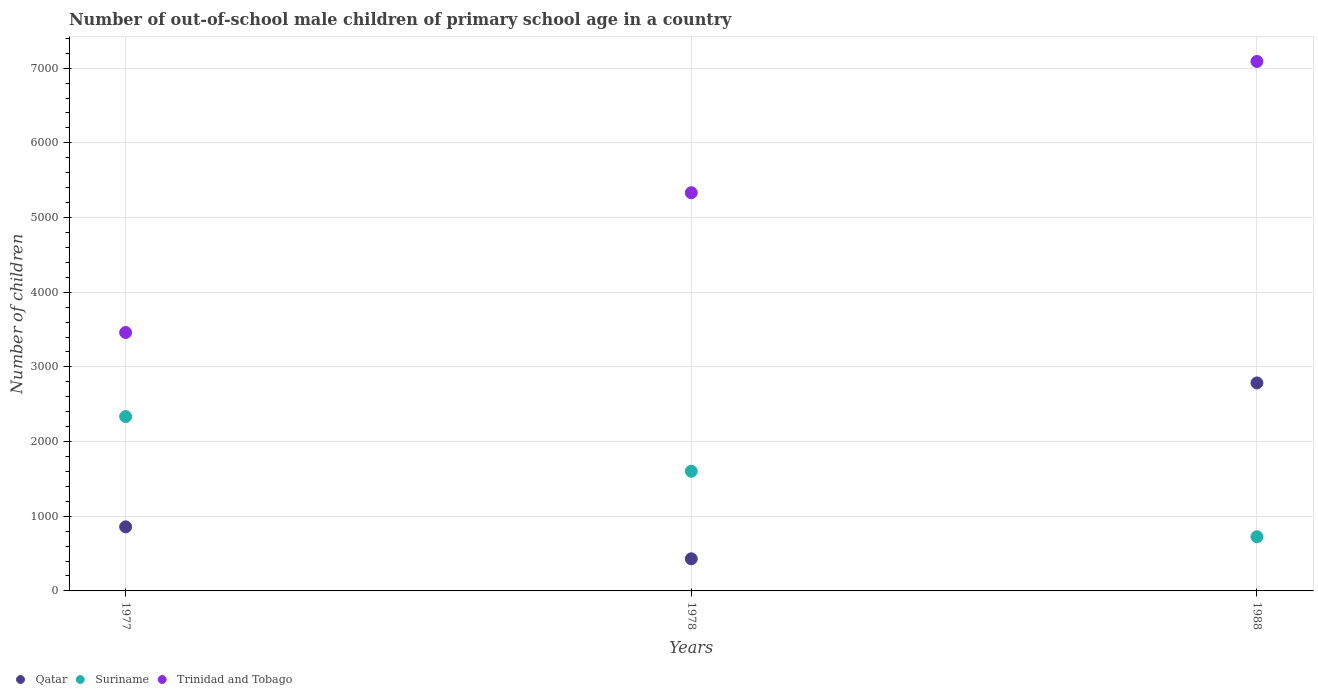How many different coloured dotlines are there?
Offer a very short reply. 3. What is the number of out-of-school male children in Suriname in 1977?
Provide a succinct answer. 2335. Across all years, what is the maximum number of out-of-school male children in Qatar?
Provide a short and direct response. 2785. Across all years, what is the minimum number of out-of-school male children in Qatar?
Ensure brevity in your answer.  430. In which year was the number of out-of-school male children in Qatar minimum?
Your answer should be very brief. 1978. What is the total number of out-of-school male children in Qatar in the graph?
Give a very brief answer. 4073. What is the difference between the number of out-of-school male children in Trinidad and Tobago in 1977 and that in 1988?
Offer a terse response. -3630. What is the difference between the number of out-of-school male children in Qatar in 1988 and the number of out-of-school male children in Trinidad and Tobago in 1978?
Ensure brevity in your answer.  -2547. What is the average number of out-of-school male children in Suriname per year?
Give a very brief answer. 1554.33. In the year 1978, what is the difference between the number of out-of-school male children in Qatar and number of out-of-school male children in Trinidad and Tobago?
Give a very brief answer. -4902. In how many years, is the number of out-of-school male children in Suriname greater than 5800?
Your response must be concise. 0. What is the ratio of the number of out-of-school male children in Suriname in 1977 to that in 1988?
Your answer should be very brief. 3.22. Is the number of out-of-school male children in Qatar in 1977 less than that in 1988?
Your response must be concise. Yes. What is the difference between the highest and the second highest number of out-of-school male children in Trinidad and Tobago?
Provide a short and direct response. 1758. What is the difference between the highest and the lowest number of out-of-school male children in Trinidad and Tobago?
Provide a short and direct response. 3630. Is it the case that in every year, the sum of the number of out-of-school male children in Trinidad and Tobago and number of out-of-school male children in Suriname  is greater than the number of out-of-school male children in Qatar?
Make the answer very short. Yes. Does the graph contain any zero values?
Your answer should be very brief. No. Does the graph contain grids?
Give a very brief answer. Yes. How many legend labels are there?
Your response must be concise. 3. What is the title of the graph?
Make the answer very short. Number of out-of-school male children of primary school age in a country. What is the label or title of the Y-axis?
Make the answer very short. Number of children. What is the Number of children in Qatar in 1977?
Your answer should be very brief. 858. What is the Number of children of Suriname in 1977?
Ensure brevity in your answer.  2335. What is the Number of children of Trinidad and Tobago in 1977?
Give a very brief answer. 3460. What is the Number of children of Qatar in 1978?
Offer a terse response. 430. What is the Number of children of Suriname in 1978?
Give a very brief answer. 1602. What is the Number of children in Trinidad and Tobago in 1978?
Offer a very short reply. 5332. What is the Number of children of Qatar in 1988?
Provide a succinct answer. 2785. What is the Number of children in Suriname in 1988?
Keep it short and to the point. 726. What is the Number of children of Trinidad and Tobago in 1988?
Your answer should be very brief. 7090. Across all years, what is the maximum Number of children of Qatar?
Provide a succinct answer. 2785. Across all years, what is the maximum Number of children in Suriname?
Ensure brevity in your answer.  2335. Across all years, what is the maximum Number of children of Trinidad and Tobago?
Provide a succinct answer. 7090. Across all years, what is the minimum Number of children in Qatar?
Make the answer very short. 430. Across all years, what is the minimum Number of children in Suriname?
Provide a succinct answer. 726. Across all years, what is the minimum Number of children in Trinidad and Tobago?
Your response must be concise. 3460. What is the total Number of children of Qatar in the graph?
Ensure brevity in your answer.  4073. What is the total Number of children of Suriname in the graph?
Give a very brief answer. 4663. What is the total Number of children of Trinidad and Tobago in the graph?
Provide a short and direct response. 1.59e+04. What is the difference between the Number of children in Qatar in 1977 and that in 1978?
Offer a very short reply. 428. What is the difference between the Number of children of Suriname in 1977 and that in 1978?
Your answer should be compact. 733. What is the difference between the Number of children of Trinidad and Tobago in 1977 and that in 1978?
Your response must be concise. -1872. What is the difference between the Number of children of Qatar in 1977 and that in 1988?
Your response must be concise. -1927. What is the difference between the Number of children in Suriname in 1977 and that in 1988?
Give a very brief answer. 1609. What is the difference between the Number of children of Trinidad and Tobago in 1977 and that in 1988?
Provide a short and direct response. -3630. What is the difference between the Number of children in Qatar in 1978 and that in 1988?
Give a very brief answer. -2355. What is the difference between the Number of children in Suriname in 1978 and that in 1988?
Make the answer very short. 876. What is the difference between the Number of children in Trinidad and Tobago in 1978 and that in 1988?
Provide a short and direct response. -1758. What is the difference between the Number of children in Qatar in 1977 and the Number of children in Suriname in 1978?
Your response must be concise. -744. What is the difference between the Number of children in Qatar in 1977 and the Number of children in Trinidad and Tobago in 1978?
Offer a terse response. -4474. What is the difference between the Number of children of Suriname in 1977 and the Number of children of Trinidad and Tobago in 1978?
Offer a very short reply. -2997. What is the difference between the Number of children in Qatar in 1977 and the Number of children in Suriname in 1988?
Provide a succinct answer. 132. What is the difference between the Number of children in Qatar in 1977 and the Number of children in Trinidad and Tobago in 1988?
Keep it short and to the point. -6232. What is the difference between the Number of children of Suriname in 1977 and the Number of children of Trinidad and Tobago in 1988?
Offer a terse response. -4755. What is the difference between the Number of children of Qatar in 1978 and the Number of children of Suriname in 1988?
Your answer should be compact. -296. What is the difference between the Number of children of Qatar in 1978 and the Number of children of Trinidad and Tobago in 1988?
Ensure brevity in your answer.  -6660. What is the difference between the Number of children in Suriname in 1978 and the Number of children in Trinidad and Tobago in 1988?
Your answer should be very brief. -5488. What is the average Number of children in Qatar per year?
Your answer should be very brief. 1357.67. What is the average Number of children of Suriname per year?
Your response must be concise. 1554.33. What is the average Number of children in Trinidad and Tobago per year?
Your answer should be very brief. 5294. In the year 1977, what is the difference between the Number of children of Qatar and Number of children of Suriname?
Provide a succinct answer. -1477. In the year 1977, what is the difference between the Number of children of Qatar and Number of children of Trinidad and Tobago?
Offer a very short reply. -2602. In the year 1977, what is the difference between the Number of children in Suriname and Number of children in Trinidad and Tobago?
Provide a succinct answer. -1125. In the year 1978, what is the difference between the Number of children in Qatar and Number of children in Suriname?
Your answer should be very brief. -1172. In the year 1978, what is the difference between the Number of children in Qatar and Number of children in Trinidad and Tobago?
Keep it short and to the point. -4902. In the year 1978, what is the difference between the Number of children in Suriname and Number of children in Trinidad and Tobago?
Provide a succinct answer. -3730. In the year 1988, what is the difference between the Number of children of Qatar and Number of children of Suriname?
Offer a terse response. 2059. In the year 1988, what is the difference between the Number of children of Qatar and Number of children of Trinidad and Tobago?
Make the answer very short. -4305. In the year 1988, what is the difference between the Number of children in Suriname and Number of children in Trinidad and Tobago?
Ensure brevity in your answer.  -6364. What is the ratio of the Number of children of Qatar in 1977 to that in 1978?
Your response must be concise. 2. What is the ratio of the Number of children in Suriname in 1977 to that in 1978?
Keep it short and to the point. 1.46. What is the ratio of the Number of children in Trinidad and Tobago in 1977 to that in 1978?
Your answer should be very brief. 0.65. What is the ratio of the Number of children of Qatar in 1977 to that in 1988?
Make the answer very short. 0.31. What is the ratio of the Number of children in Suriname in 1977 to that in 1988?
Keep it short and to the point. 3.22. What is the ratio of the Number of children of Trinidad and Tobago in 1977 to that in 1988?
Keep it short and to the point. 0.49. What is the ratio of the Number of children in Qatar in 1978 to that in 1988?
Offer a terse response. 0.15. What is the ratio of the Number of children in Suriname in 1978 to that in 1988?
Your answer should be very brief. 2.21. What is the ratio of the Number of children in Trinidad and Tobago in 1978 to that in 1988?
Your answer should be very brief. 0.75. What is the difference between the highest and the second highest Number of children of Qatar?
Your answer should be very brief. 1927. What is the difference between the highest and the second highest Number of children in Suriname?
Make the answer very short. 733. What is the difference between the highest and the second highest Number of children in Trinidad and Tobago?
Offer a terse response. 1758. What is the difference between the highest and the lowest Number of children of Qatar?
Offer a very short reply. 2355. What is the difference between the highest and the lowest Number of children in Suriname?
Offer a very short reply. 1609. What is the difference between the highest and the lowest Number of children in Trinidad and Tobago?
Give a very brief answer. 3630. 